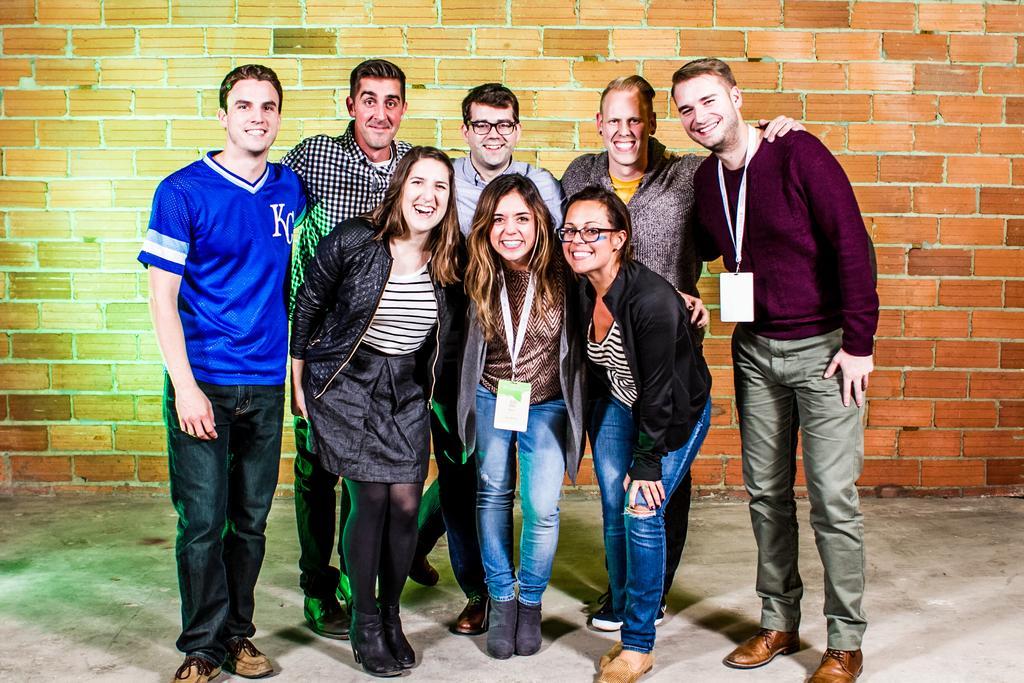In one or two sentences, can you explain what this image depicts? In this image at front people are standing on the floor. At the back side there is a wall. 